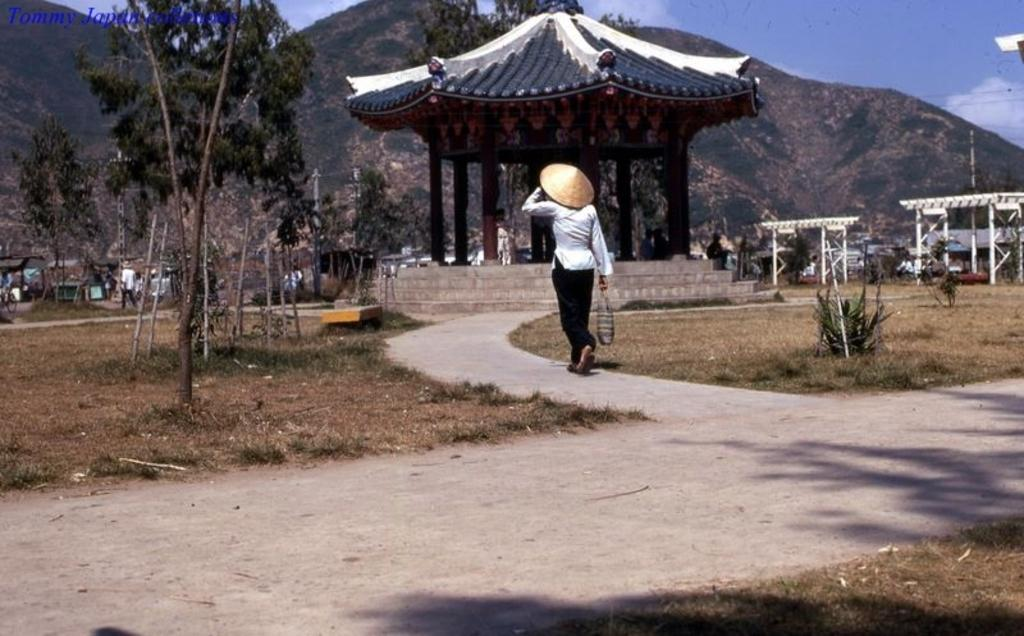How many people can be seen in the image? There are people in the image, but the exact number is not specified. What type of natural elements are present in the image? There are trees and plants in the image. What kind of structure is visible in the image? There is a Chinese house without side walls in the image. What other objects can be seen in the image? There are poles and wires in the image. What can be seen in the background of the image? Mountains and the sky are visible in the background of the image. What type of pickle is being used to control the playground equipment in the image? There is no pickle or playground equipment present in the image. 